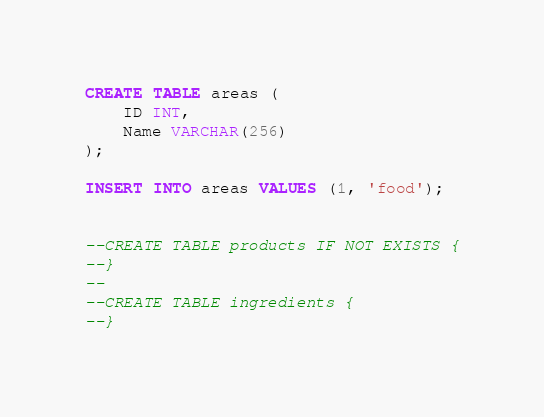<code> <loc_0><loc_0><loc_500><loc_500><_SQL_>
CREATE TABLE areas (
    ID INT,
    Name VARCHAR(256)
);

INSERT INTO areas VALUES (1, 'food');


--CREATE TABLE products IF NOT EXISTS {
--}
--
--CREATE TABLE ingredients {
--}
</code> 